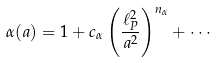Convert formula to latex. <formula><loc_0><loc_0><loc_500><loc_500>\alpha ( a ) = 1 + c _ { \alpha } \left ( \frac { \ell _ { P } ^ { 2 } } { a ^ { 2 } } \right ) ^ { n _ { \alpha } } + \cdots</formula> 